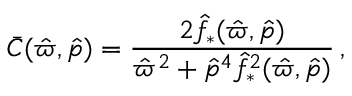<formula> <loc_0><loc_0><loc_500><loc_500>\bar { C } ( \hat { \varpi } , \hat { p } ) = \frac { 2 { \hat { f } _ { * } } ( \hat { \varpi } , \hat { p } ) } { \hat { \varpi } ^ { 2 } + \hat { p } ^ { 4 } { \hat { f } _ { * } } ^ { 2 } ( \hat { \varpi } , \hat { p } ) } \, ,</formula> 